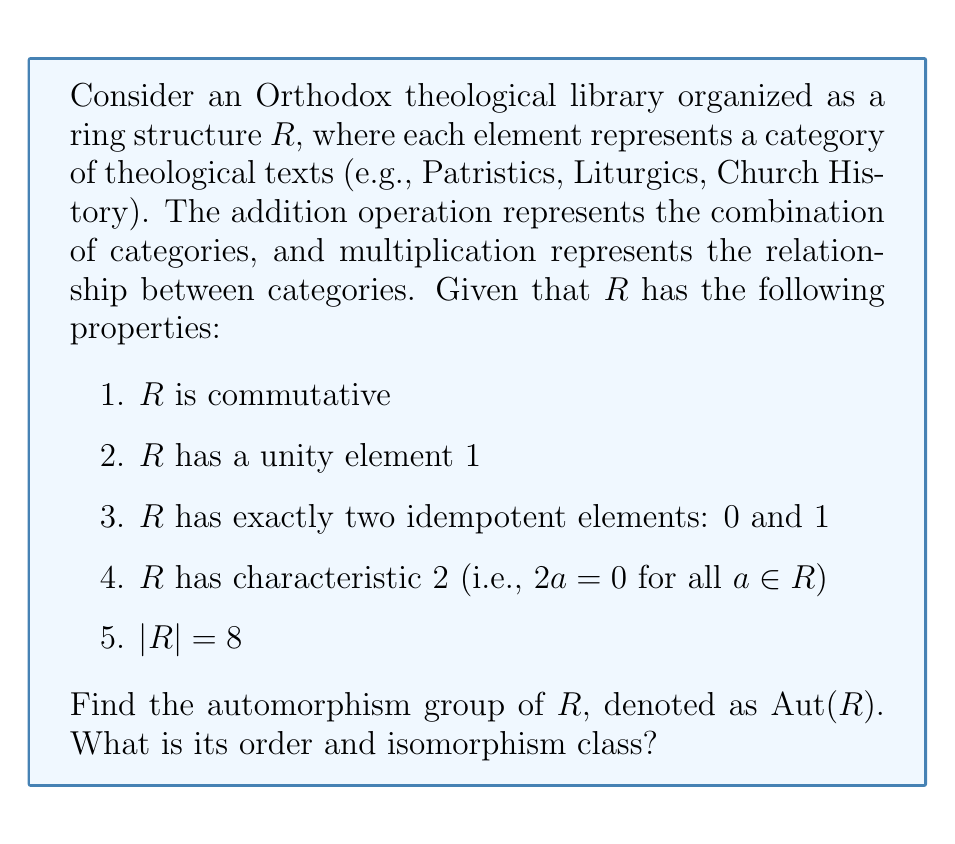What is the answer to this math problem? Let's approach this step-by-step:

1) First, we need to identify the structure of $R$. Given the properties, we can deduce that $R$ is isomorphic to the finite field $\mathbb{F}_8$, which is the unique (up to isomorphism) field with 8 elements.

2) In $\mathbb{F}_8$, we can represent elements as polynomials over $\mathbb{F}_2$ modulo an irreducible polynomial of degree 3. Let's use $x^3 + x + 1$ as our irreducible polynomial.

3) The automorphism group of a finite field is cyclic and generated by the Frobenius automorphism. For $\mathbb{F}_{p^n}$, the order of the automorphism group is $n$.

4) In our case, $p = 2$ and $n = 3$, so $|Aut(R)| = 3$.

5) The Frobenius automorphism $\phi$ in this case maps $a \mapsto a^2$ for all $a \in R$. It has order 3 because:
   
   $\phi^3(a) = (a^2)^2)^2 = a^8 = a$ (since $a^7 = 1$ for all non-zero $a$ in $\mathbb{F}_8$)

6) Therefore, $Aut(R) = \{id, \phi, \phi^2\}$, where $id$ is the identity automorphism.

7) A cyclic group of order 3 is isomorphic to $\mathbb{Z}_3$, the additive group of integers modulo 3.
Answer: The automorphism group $Aut(R)$ is cyclic of order 3, isomorphic to $\mathbb{Z}_3$. 